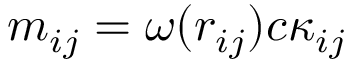<formula> <loc_0><loc_0><loc_500><loc_500>m _ { i j } = \omega ( r _ { i j } ) c \kappa _ { i j }</formula> 